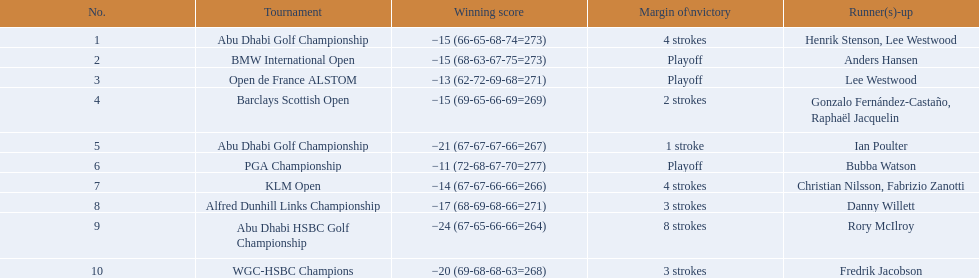Who had the top score in the pga championship? Bubba Watson. 